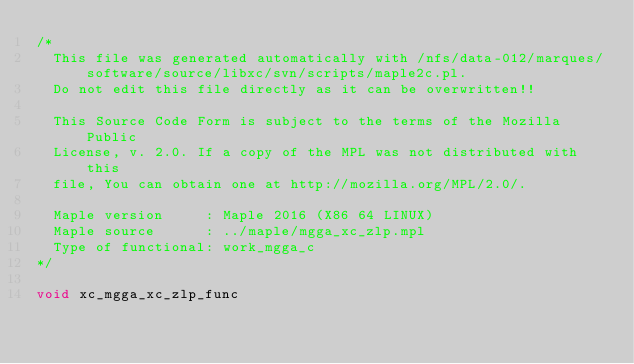Convert code to text. <code><loc_0><loc_0><loc_500><loc_500><_C_>/* 
  This file was generated automatically with /nfs/data-012/marques/software/source/libxc/svn/scripts/maple2c.pl.
  Do not edit this file directly as it can be overwritten!!

  This Source Code Form is subject to the terms of the Mozilla Public
  License, v. 2.0. If a copy of the MPL was not distributed with this
  file, You can obtain one at http://mozilla.org/MPL/2.0/.

  Maple version     : Maple 2016 (X86 64 LINUX)
  Maple source      : ../maple/mgga_xc_zlp.mpl
  Type of functional: work_mgga_c
*/

void xc_mgga_xc_zlp_func</code> 